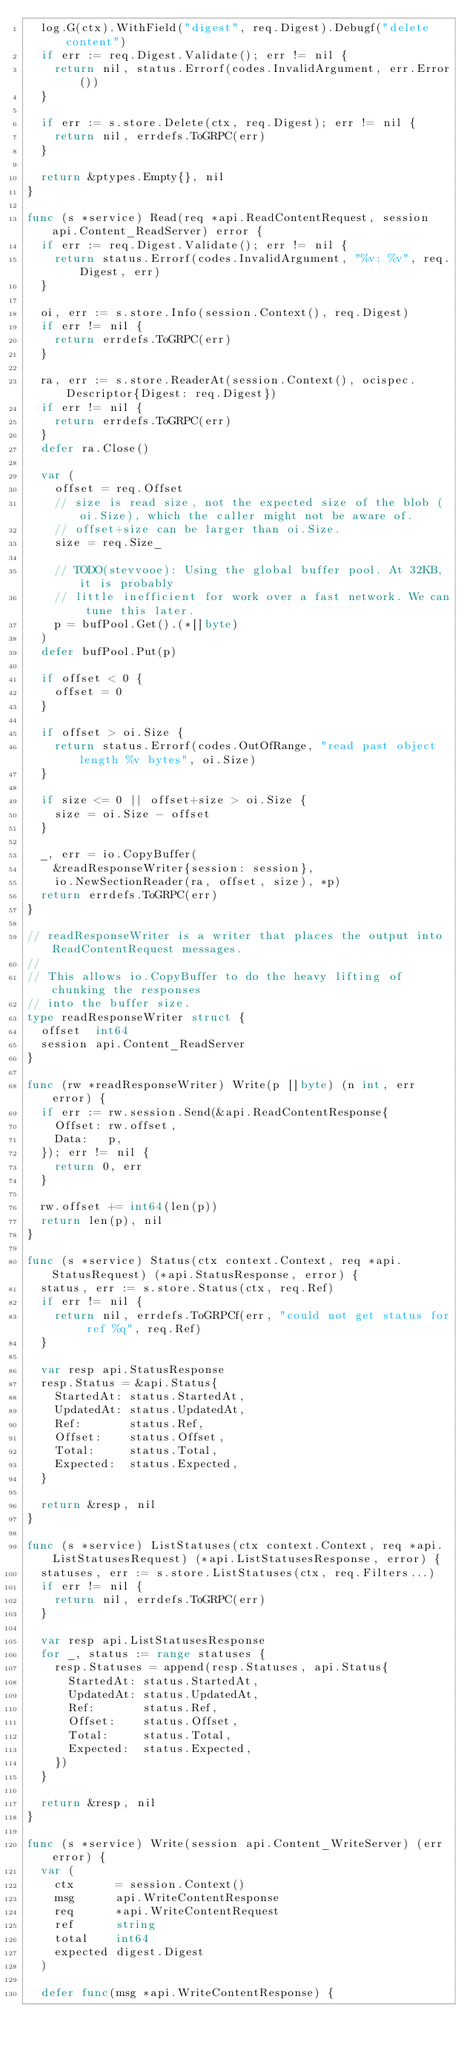Convert code to text. <code><loc_0><loc_0><loc_500><loc_500><_Go_>	log.G(ctx).WithField("digest", req.Digest).Debugf("delete content")
	if err := req.Digest.Validate(); err != nil {
		return nil, status.Errorf(codes.InvalidArgument, err.Error())
	}

	if err := s.store.Delete(ctx, req.Digest); err != nil {
		return nil, errdefs.ToGRPC(err)
	}

	return &ptypes.Empty{}, nil
}

func (s *service) Read(req *api.ReadContentRequest, session api.Content_ReadServer) error {
	if err := req.Digest.Validate(); err != nil {
		return status.Errorf(codes.InvalidArgument, "%v: %v", req.Digest, err)
	}

	oi, err := s.store.Info(session.Context(), req.Digest)
	if err != nil {
		return errdefs.ToGRPC(err)
	}

	ra, err := s.store.ReaderAt(session.Context(), ocispec.Descriptor{Digest: req.Digest})
	if err != nil {
		return errdefs.ToGRPC(err)
	}
	defer ra.Close()

	var (
		offset = req.Offset
		// size is read size, not the expected size of the blob (oi.Size), which the caller might not be aware of.
		// offset+size can be larger than oi.Size.
		size = req.Size_

		// TODO(stevvooe): Using the global buffer pool. At 32KB, it is probably
		// little inefficient for work over a fast network. We can tune this later.
		p = bufPool.Get().(*[]byte)
	)
	defer bufPool.Put(p)

	if offset < 0 {
		offset = 0
	}

	if offset > oi.Size {
		return status.Errorf(codes.OutOfRange, "read past object length %v bytes", oi.Size)
	}

	if size <= 0 || offset+size > oi.Size {
		size = oi.Size - offset
	}

	_, err = io.CopyBuffer(
		&readResponseWriter{session: session},
		io.NewSectionReader(ra, offset, size), *p)
	return errdefs.ToGRPC(err)
}

// readResponseWriter is a writer that places the output into ReadContentRequest messages.
//
// This allows io.CopyBuffer to do the heavy lifting of chunking the responses
// into the buffer size.
type readResponseWriter struct {
	offset  int64
	session api.Content_ReadServer
}

func (rw *readResponseWriter) Write(p []byte) (n int, err error) {
	if err := rw.session.Send(&api.ReadContentResponse{
		Offset: rw.offset,
		Data:   p,
	}); err != nil {
		return 0, err
	}

	rw.offset += int64(len(p))
	return len(p), nil
}

func (s *service) Status(ctx context.Context, req *api.StatusRequest) (*api.StatusResponse, error) {
	status, err := s.store.Status(ctx, req.Ref)
	if err != nil {
		return nil, errdefs.ToGRPCf(err, "could not get status for ref %q", req.Ref)
	}

	var resp api.StatusResponse
	resp.Status = &api.Status{
		StartedAt: status.StartedAt,
		UpdatedAt: status.UpdatedAt,
		Ref:       status.Ref,
		Offset:    status.Offset,
		Total:     status.Total,
		Expected:  status.Expected,
	}

	return &resp, nil
}

func (s *service) ListStatuses(ctx context.Context, req *api.ListStatusesRequest) (*api.ListStatusesResponse, error) {
	statuses, err := s.store.ListStatuses(ctx, req.Filters...)
	if err != nil {
		return nil, errdefs.ToGRPC(err)
	}

	var resp api.ListStatusesResponse
	for _, status := range statuses {
		resp.Statuses = append(resp.Statuses, api.Status{
			StartedAt: status.StartedAt,
			UpdatedAt: status.UpdatedAt,
			Ref:       status.Ref,
			Offset:    status.Offset,
			Total:     status.Total,
			Expected:  status.Expected,
		})
	}

	return &resp, nil
}

func (s *service) Write(session api.Content_WriteServer) (err error) {
	var (
		ctx      = session.Context()
		msg      api.WriteContentResponse
		req      *api.WriteContentRequest
		ref      string
		total    int64
		expected digest.Digest
	)

	defer func(msg *api.WriteContentResponse) {</code> 